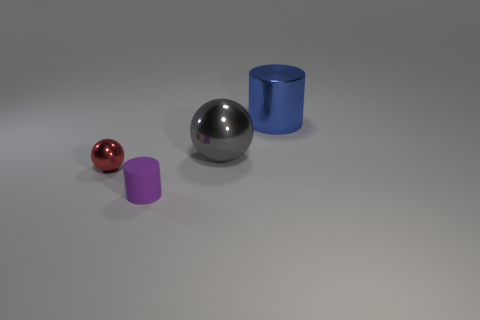Add 3 tiny purple matte objects. How many objects exist? 7 Subtract all green balls. How many red cylinders are left? 0 Subtract all tiny spheres. Subtract all tiny cyan metallic cylinders. How many objects are left? 3 Add 1 purple things. How many purple things are left? 2 Add 2 tiny green rubber things. How many tiny green rubber things exist? 2 Subtract 0 red cylinders. How many objects are left? 4 Subtract 1 cylinders. How many cylinders are left? 1 Subtract all brown balls. Subtract all green cylinders. How many balls are left? 2 